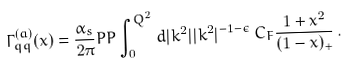<formula> <loc_0><loc_0><loc_500><loc_500>\Gamma _ { q q } ^ { ( a ) } ( x ) = \frac { \alpha _ { s } } { 2 \pi } P P \int _ { 0 } ^ { Q ^ { 2 } } d | k ^ { 2 } | | k ^ { 2 } | ^ { - 1 - \epsilon } \, C _ { F } \frac { 1 + x ^ { 2 } } { ( 1 - x ) _ { + } } \, .</formula> 